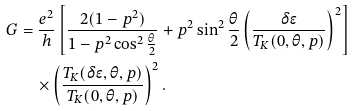<formula> <loc_0><loc_0><loc_500><loc_500>G & = \frac { e ^ { 2 } } { h } \left [ \frac { 2 ( 1 - p ^ { 2 } ) } { 1 - p ^ { 2 } \cos ^ { 2 } \frac { \theta } { 2 } } + p ^ { 2 } \sin ^ { 2 } \frac { \theta } { 2 } \left ( \frac { \delta \epsilon } { T _ { K } ( 0 , \theta , p ) } \right ) ^ { 2 } \right ] \\ & \quad \times \left ( \frac { T _ { K } ( \delta \epsilon , \theta , p ) } { T _ { K } ( 0 , \theta , p ) } \right ) ^ { 2 } .</formula> 